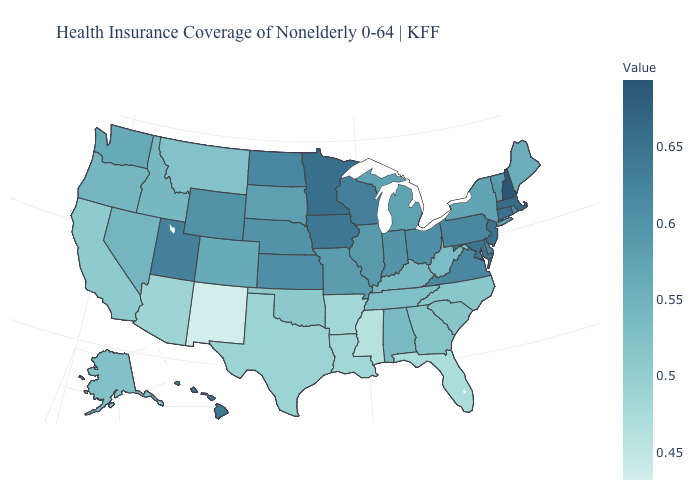Which states have the highest value in the USA?
Be succinct. New Hampshire. Does Maryland have the lowest value in the USA?
Answer briefly. No. Does Maine have the lowest value in the Northeast?
Write a very short answer. Yes. Does the map have missing data?
Keep it brief. No. Among the states that border Delaware , does Pennsylvania have the lowest value?
Give a very brief answer. Yes. 